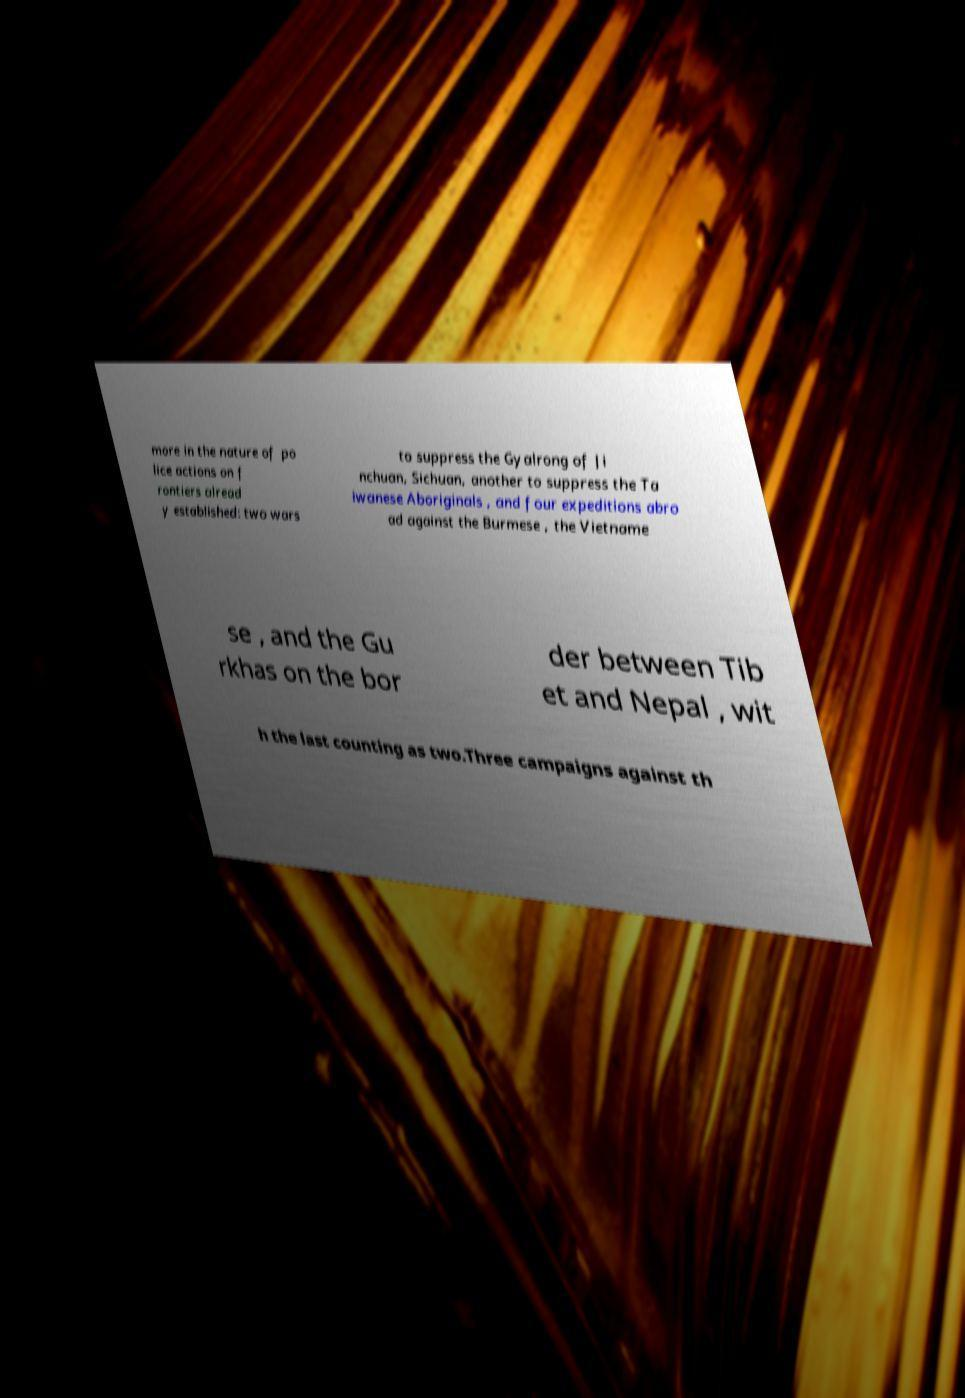For documentation purposes, I need the text within this image transcribed. Could you provide that? more in the nature of po lice actions on f rontiers alread y established: two wars to suppress the Gyalrong of Ji nchuan, Sichuan, another to suppress the Ta iwanese Aboriginals , and four expeditions abro ad against the Burmese , the Vietname se , and the Gu rkhas on the bor der between Tib et and Nepal , wit h the last counting as two.Three campaigns against th 